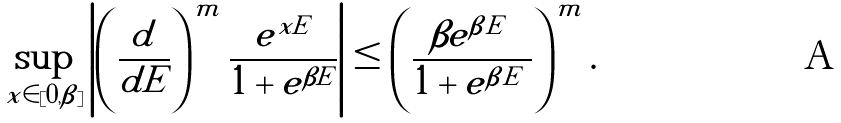Convert formula to latex. <formula><loc_0><loc_0><loc_500><loc_500>\sup _ { x \in [ 0 , \beta ] } \left | \left ( \frac { d } { d E } \right ) ^ { m } \frac { e ^ { x E } } { 1 + e ^ { \beta E } } \right | \leq \left ( \frac { \beta e ^ { \beta | E | } } { 1 + e ^ { \beta | E | } } \right ) ^ { m } .</formula> 